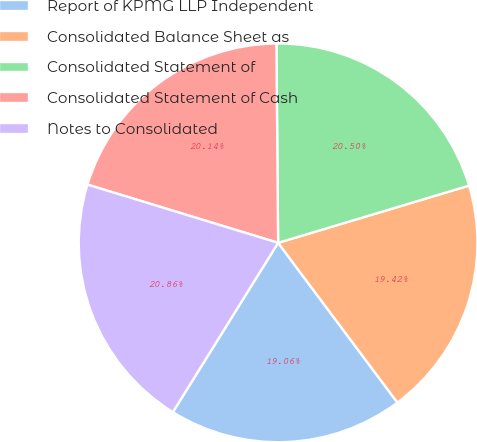Convert chart to OTSL. <chart><loc_0><loc_0><loc_500><loc_500><pie_chart><fcel>Report of KPMG LLP Independent<fcel>Consolidated Balance Sheet as<fcel>Consolidated Statement of<fcel>Consolidated Statement of Cash<fcel>Notes to Consolidated<nl><fcel>19.06%<fcel>19.42%<fcel>20.5%<fcel>20.14%<fcel>20.86%<nl></chart> 